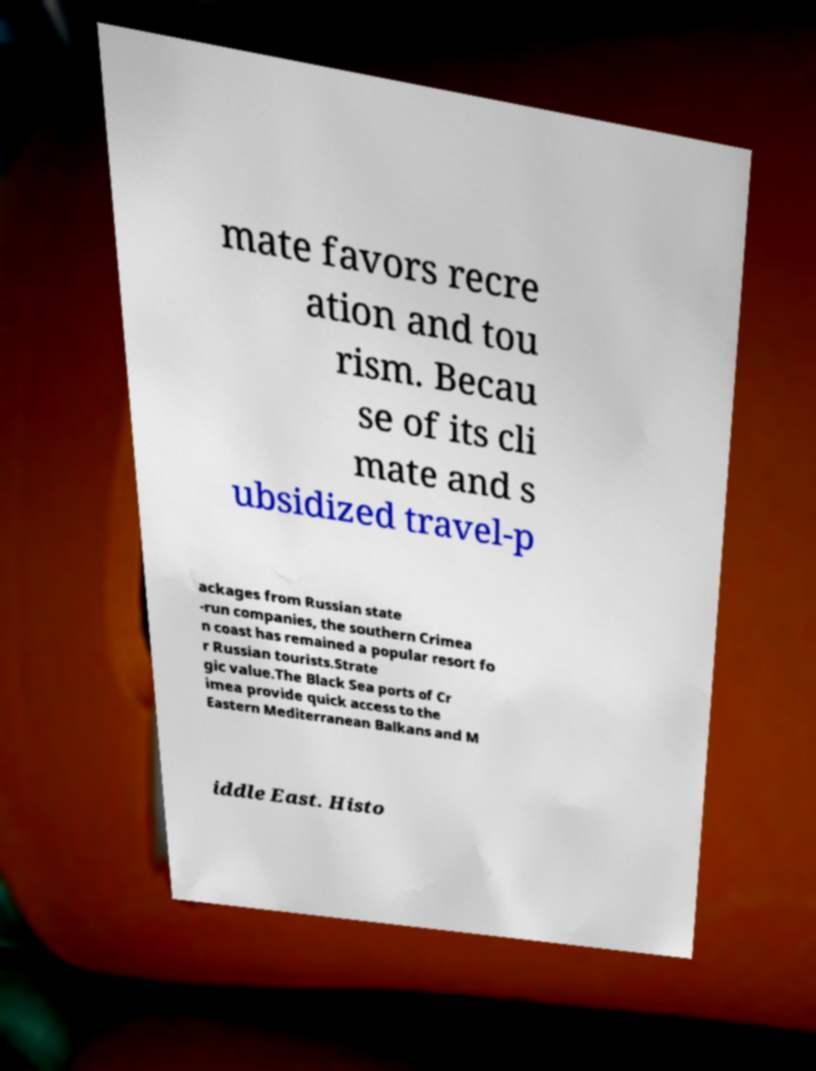I need the written content from this picture converted into text. Can you do that? mate favors recre ation and tou rism. Becau se of its cli mate and s ubsidized travel-p ackages from Russian state -run companies, the southern Crimea n coast has remained a popular resort fo r Russian tourists.Strate gic value.The Black Sea ports of Cr imea provide quick access to the Eastern Mediterranean Balkans and M iddle East. Histo 